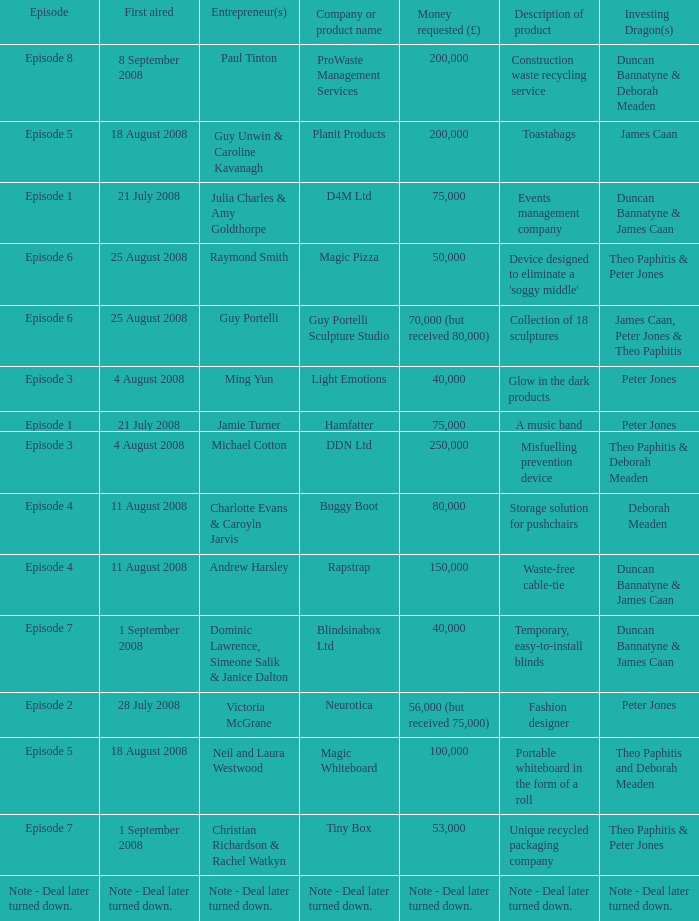How much money did the company Neurotica request? 56,000 (but received 75,000). 